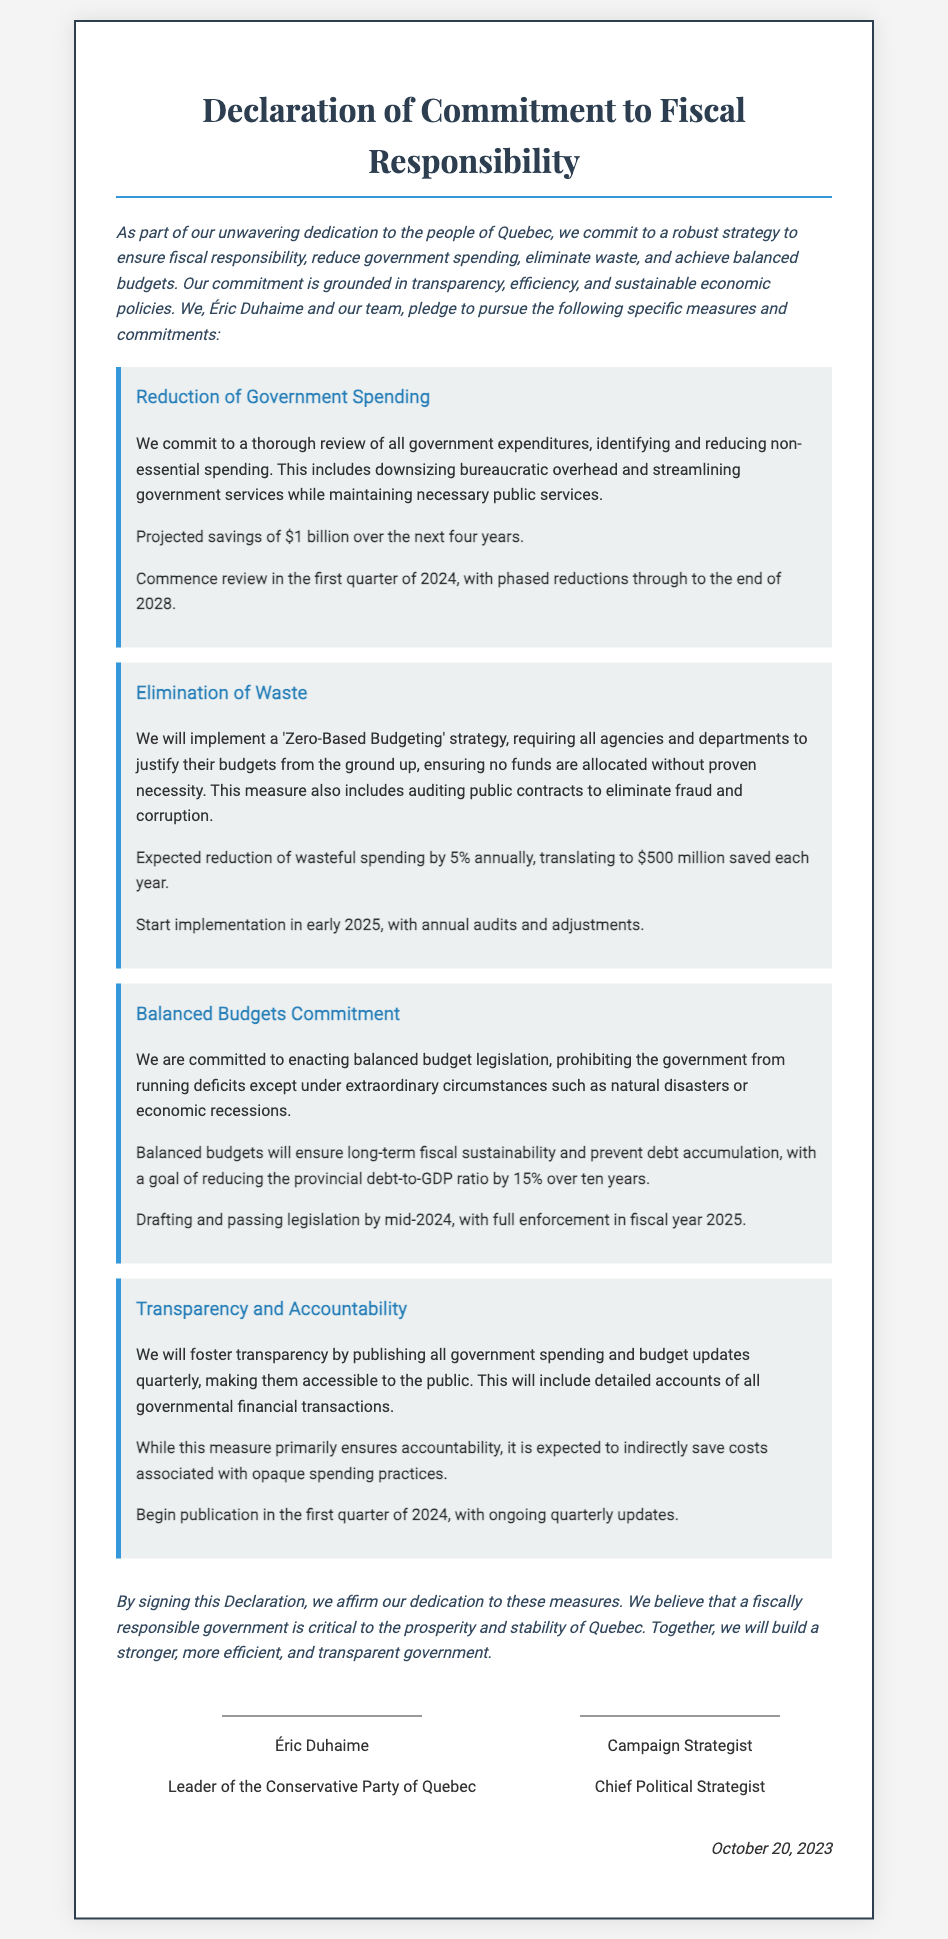What is the projected savings from the reduction of government spending? The projected savings is outlined in the document, stating that there will be savings of $1 billion over the next four years.
Answer: $1 billion What is the expected annual reduction of wasteful spending? The document specifies that the expected reduction of wasteful spending is 5% annually.
Answer: 5% When will the review of government expenditures commence? According to the timeline in the document, the review of government expenditures will begin in the first quarter of 2024.
Answer: First quarter of 2024 What fiscal policy is proposed to ensure long-term sustainability? The document outlines that balanced budget legislation is proposed to ensure long-term fiscal sustainability.
Answer: Balanced budget legislation What will the debt-to-GDP ratio reduction goal be over the next ten years? The document mentions that the goal is to reduce the provincial debt-to-GDP ratio by 15% over ten years.
Answer: 15% What is the signing date of the Declaration? The signing date is explicitly stated in the document at the end.
Answer: October 20, 2023 Who is identified as the Leader of the Conservative Party of Quebec? The document provides this information, naming Éric Duhaime as the Leader of the Conservative Party of Quebec.
Answer: Éric Duhaime What strategy will be implemented to foster transparency? The document describes the strategy of publishing all government spending and budget updates quarterly to ensure transparency.
Answer: Publishing quarterly updates What is the first measure mentioned in the Declaration? The first measure highlighted in the document is the reduction of government spending.
Answer: Reduction of Government Spending 